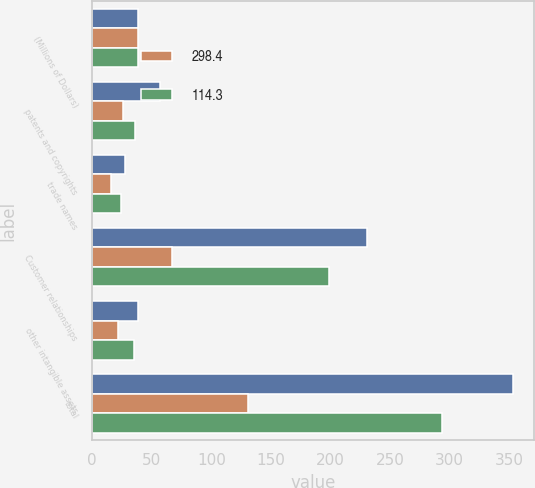<chart> <loc_0><loc_0><loc_500><loc_500><stacked_bar_chart><ecel><fcel>(Millions of Dollars)<fcel>patents and copyrights<fcel>trade names<fcel>Customer relationships<fcel>other intangible assets<fcel>total<nl><fcel>nan<fcel>38.5<fcel>57<fcel>27.7<fcel>230.4<fcel>38.5<fcel>353.6<nl><fcel>298.4<fcel>38.5<fcel>26.1<fcel>15.5<fcel>67.1<fcel>22<fcel>130.7<nl><fcel>114.3<fcel>38.5<fcel>35.7<fcel>24.2<fcel>198.7<fcel>35.3<fcel>293.9<nl></chart> 